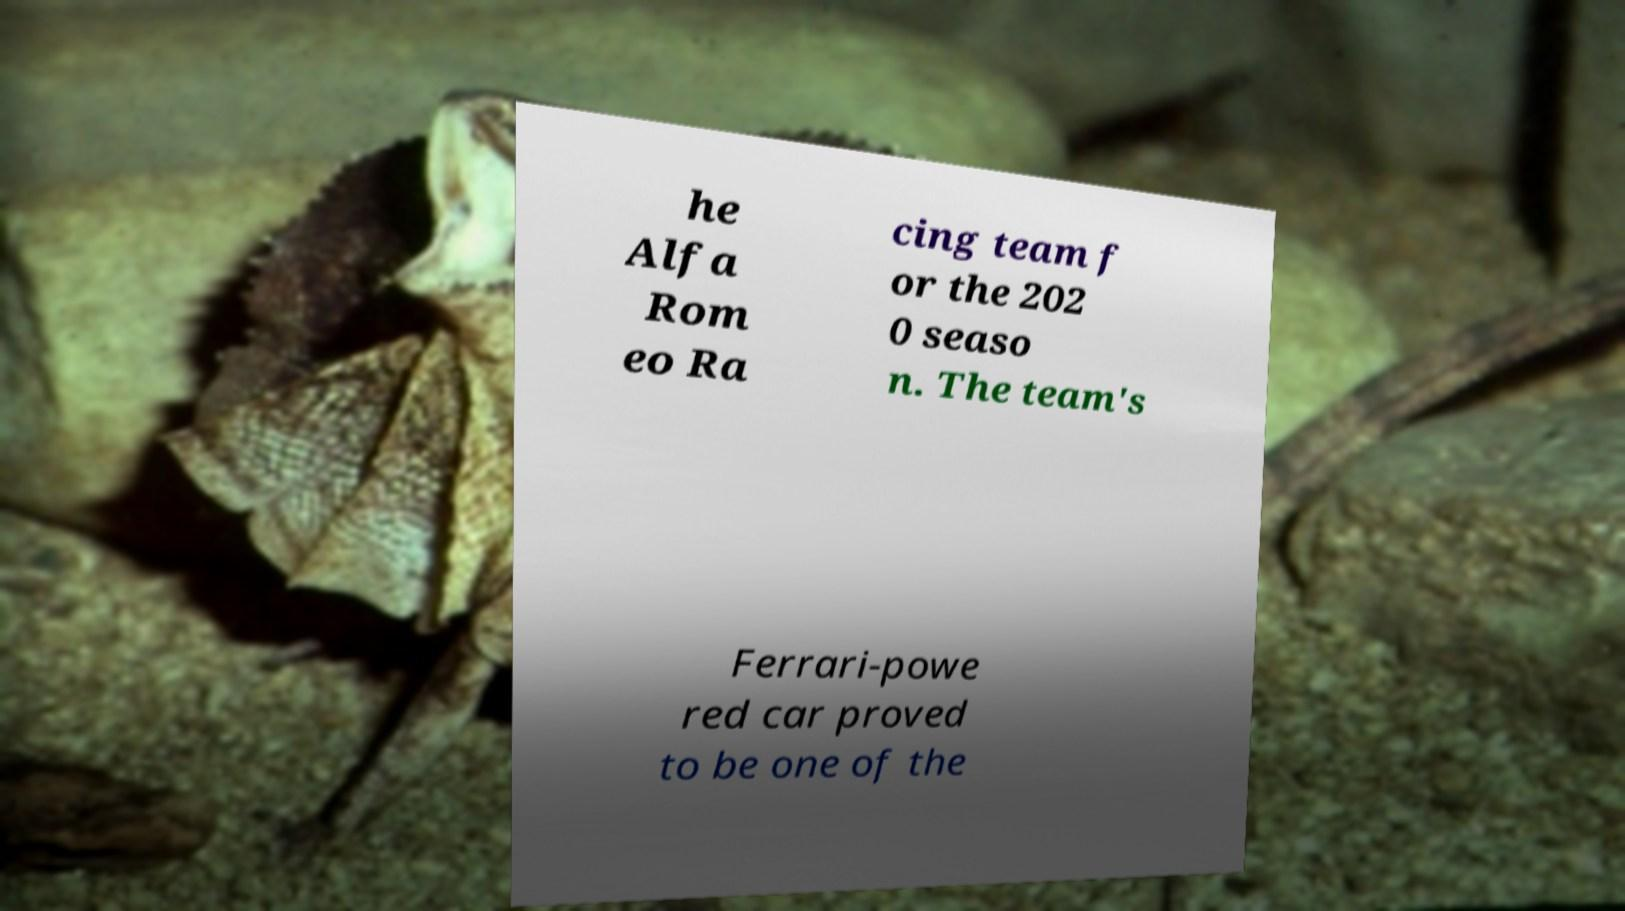Could you extract and type out the text from this image? he Alfa Rom eo Ra cing team f or the 202 0 seaso n. The team's Ferrari-powe red car proved to be one of the 